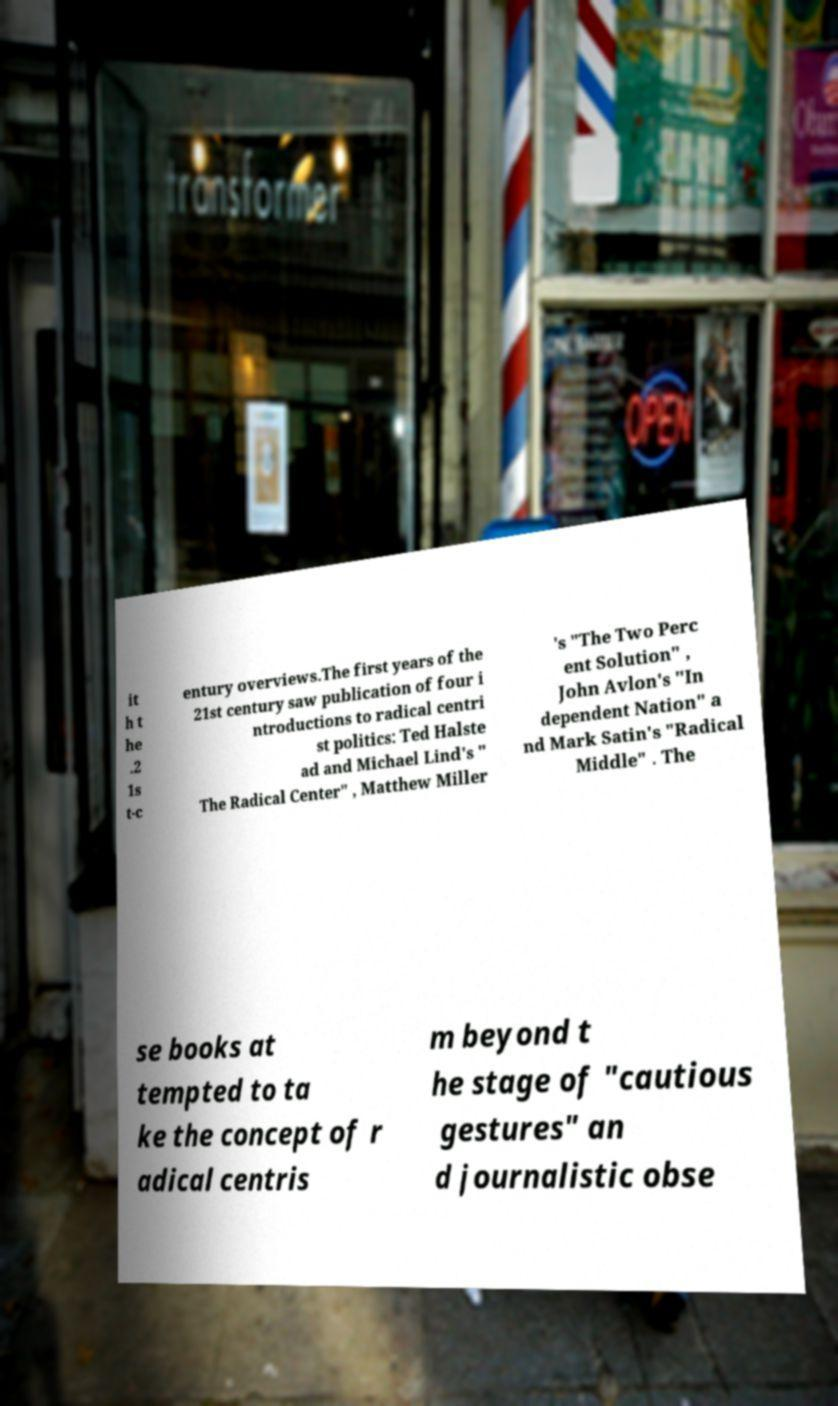Can you accurately transcribe the text from the provided image for me? it h t he .2 1s t-c entury overviews.The first years of the 21st century saw publication of four i ntroductions to radical centri st politics: Ted Halste ad and Michael Lind's " The Radical Center" , Matthew Miller 's "The Two Perc ent Solution" , John Avlon's "In dependent Nation" a nd Mark Satin's "Radical Middle" . The se books at tempted to ta ke the concept of r adical centris m beyond t he stage of "cautious gestures" an d journalistic obse 